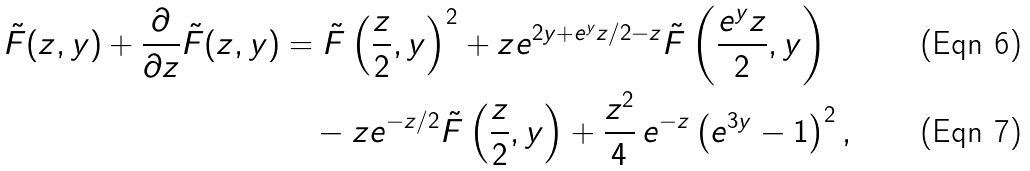<formula> <loc_0><loc_0><loc_500><loc_500>\tilde { F } ( z , y ) + \frac { \partial } { \partial z } \tilde { F } ( z , y ) & = \tilde { F } \left ( \frac { z } { 2 } , y \right ) ^ { 2 } + z e ^ { 2 y + e ^ { y } z / 2 - z } \tilde { F } \left ( \frac { e ^ { y } z } 2 , y \right ) \\ & \quad - z e ^ { - z / 2 } \tilde { F } \left ( \frac { z } { 2 } , y \right ) + \frac { z ^ { 2 } } 4 \, e ^ { - z } \left ( e ^ { 3 y } - 1 \right ) ^ { 2 } ,</formula> 